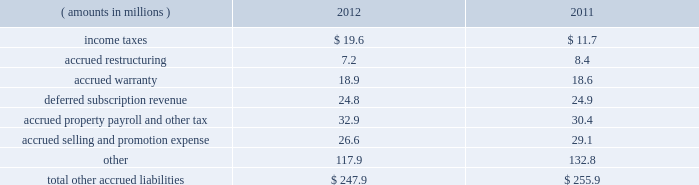Notes to consolidated financial statements ( continued ) management performs detailed reviews of its receivables on a monthly and/or quarterly basis to assess the adequacy of the allowances based on historical and current trends and other factors affecting credit losses and to determine if any impairment has occurred .
A receivable is impaired when it is probable that all amounts related to the receivable will not be collected according to the contractual terms of the agreement .
In circumstances where the company is aware of a specific customer 2019s inability to meet its financial obligations , a specific reserve is recorded against amounts due to reduce the net recognized receivable to the amount reasonably expected to be collected .
Additions to the allowances for doubtful accounts are maintained through adjustments to the provision for credit losses , which are charged to current period earnings ; amounts determined to be uncollectable are charged directly against the allowances , while amounts recovered on previously charged-off accounts increase the allowances .
Net charge-offs include the principal amount of losses charged off as well as charged-off interest and fees .
Recovered interest and fees previously charged-off are recorded through the allowances for doubtful accounts and increase the allowances .
Finance receivables are assessed for charge- off when an account becomes 120 days past due and are charged-off typically within 60 days of asset repossession .
Contract receivables related to equipment leases are generally charged-off when an account becomes 150 days past due , while contract receivables related to franchise finance and van leases are generally charged off up to 180 days past the asset return .
For finance and contract receivables , customer bankruptcies are generally charged-off upon notification that the associated debt is not being reaffirmed or , in any event , no later than 180 days past due .
Snap-on does not believe that its trade accounts , finance or contract receivables represent significant concentrations of credit risk because of the diversified portfolio of individual customers and geographical areas .
See note 3 for further information on receivables and allowances for doubtful accounts .
Other accrued liabilities : supplemental balance sheet information for 201cother accrued liabilities 201d as of 2012 and 2011 year end is as follows : ( amounts in millions ) 2012 2011 .
Inventories : snap-on values its inventory at the lower of cost or market and adjusts for the value of inventory that is estimated to be excess , obsolete or otherwise unmarketable .
Snap-on records allowances for excess and obsolete inventory based on historical and estimated future demand and market conditions .
Allowances for raw materials are largely based on an analysis of raw material age and actual physical inspection of raw material for fitness for use .
As part of evaluating the adequacy of allowances for work-in-progress and finished goods , management reviews individual product stock-keeping units ( skus ) by product category and product life cycle .
Cost adjustments for each product category/product life-cycle state are generally established and maintained based on a combination of historical experience , forecasted sales and promotions , technological obsolescence , inventory age and other actual known conditions and circumstances .
Should actual product marketability and raw material fitness for use be affected by conditions that are different from management estimates , further adjustments to inventory allowances may be required .
Snap-on adopted the 201clast-in , first-out 201d ( 201clifo 201d ) inventory valuation method in 1973 for its u.s .
Locations .
Snap-on 2019s u.s .
Inventories accounted for on a lifo basis consist of purchased product and inventory manufactured at the company 2019s heritage u.s .
Manufacturing facilities ( primarily hand tools and tool storage ) .
As snap-on began acquiring businesses in the 1990 2019s , the company retained the 201cfirst-in , first-out 201d ( 201cfifo 201d ) inventory valuation methodology used by the predecessor businesses prior to their acquisition by snap-on ; the company does not adopt the lifo inventory valuation methodology for new acquisitions .
See note 4 for further information on inventories .
72 snap-on incorporated .
What was the percent of income taxes as part of the the total other accrued liabilities in 2012? 
Computations: (19.6 / 247.9)
Answer: 0.07906. 